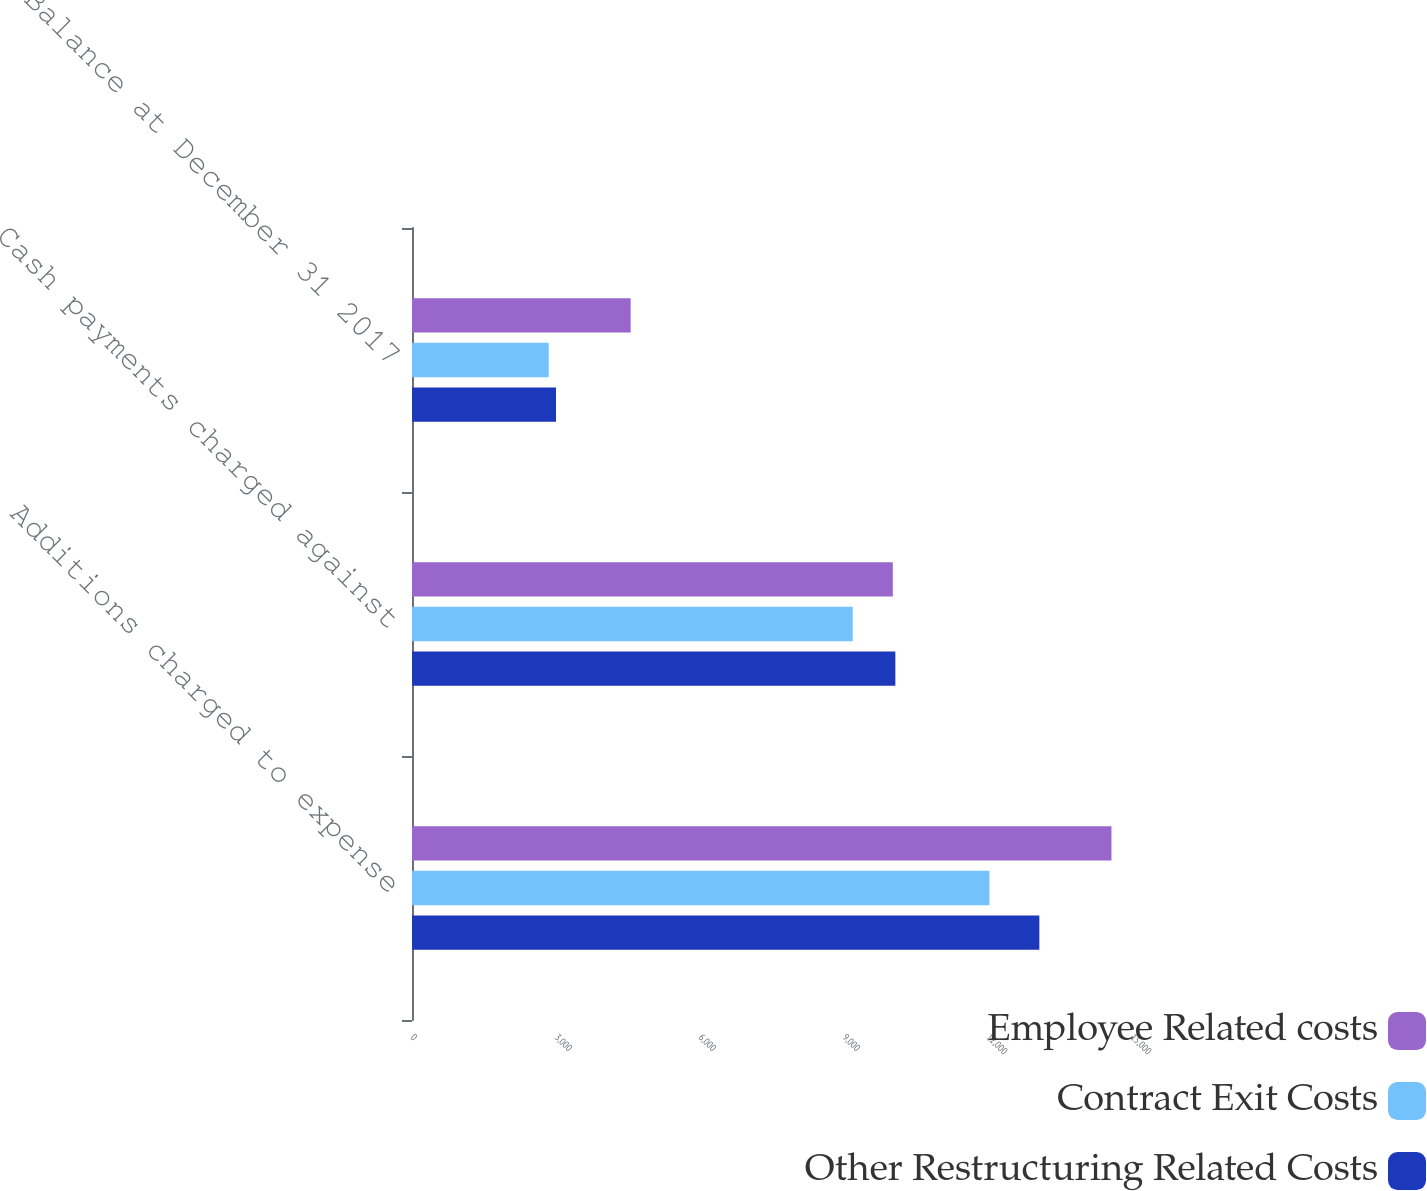Convert chart to OTSL. <chart><loc_0><loc_0><loc_500><loc_500><stacked_bar_chart><ecel><fcel>Additions charged to expense<fcel>Cash payments charged against<fcel>Balance at December 31 2017<nl><fcel>Employee Related costs<fcel>14572<fcel>10017<fcel>4555<nl><fcel>Contract Exit Costs<fcel>12029<fcel>9181<fcel>2848<nl><fcel>Other Restructuring Related Costs<fcel>13070<fcel>10070<fcel>3000<nl></chart> 